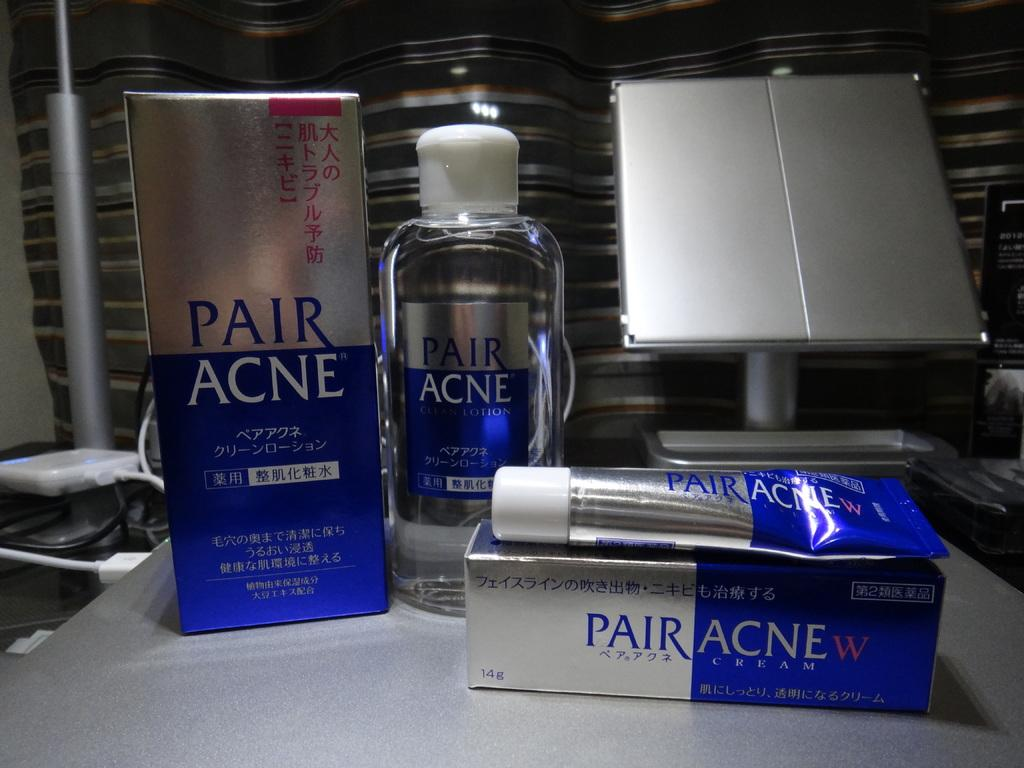What object can be seen in the image that is typically used for holding liquids? There is a bottle in the image. What other object can be seen in the image that is related to skincare? There is a tube in the image, and it has "pair acne" written on it. Where are the bottle and tube located in the image? The bottle and tube are on a table. What can be seen behind the table in the image? The background of the image is a steel wall. What type of egg is being used as a ticket in the image? There is no egg or ticket present in the image. 